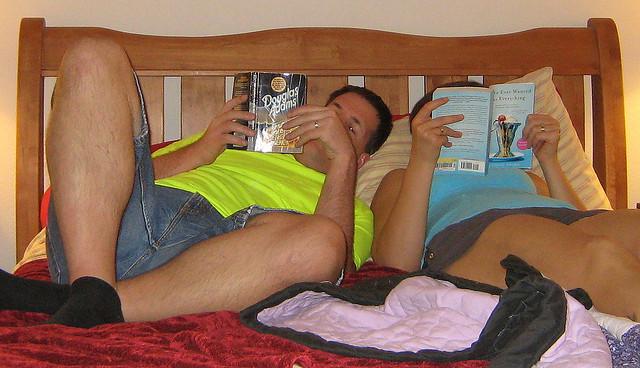Are the two people reading the same book?
Keep it brief. No. Are these people the same gender?
Short answer required. No. What are the people sitting on?
Write a very short answer. Bed. 